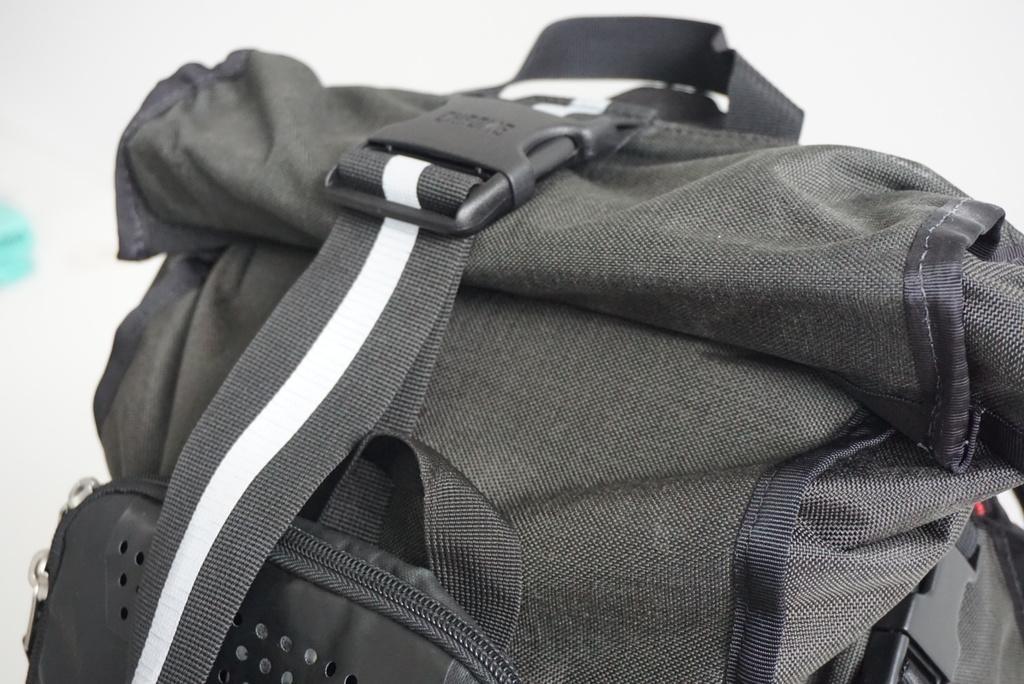Please provide a concise description of this image. In this image i can see a green color trekking bag. 